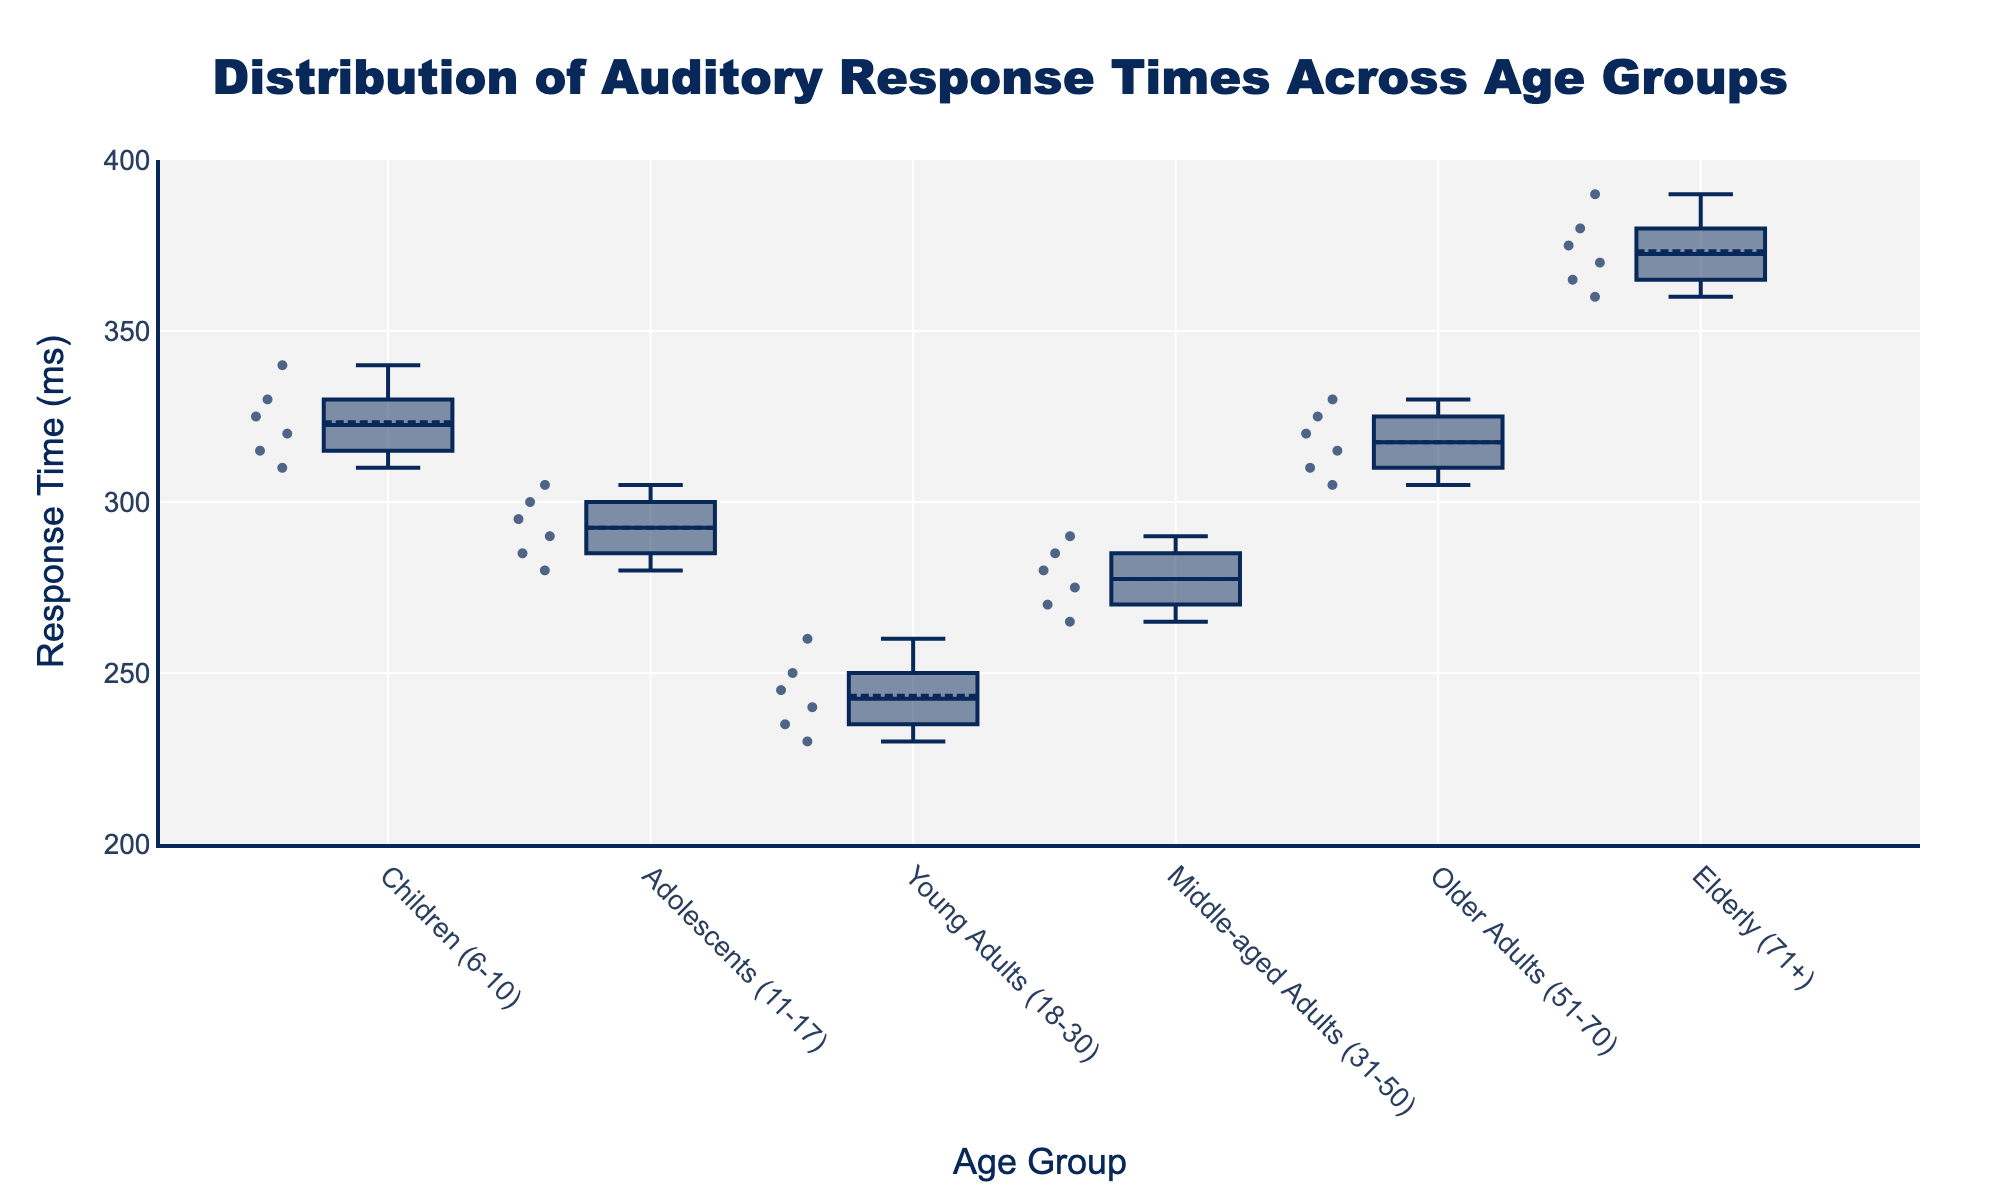What is the title of the figure? The title of the figure is typically found at the top and centers the main concept being visualized. In this case, it is "Distribution of Auditory Response Times Across Age Groups" as mentioned in the code provided.
Answer: Distribution of Auditory Response Times Across Age Groups Which age group has the highest median response time? To find the age group with the highest median, locate the median line inside the boxes of each age group. The highest median line is found in the "Elderly (71+)" group.
Answer: Elderly (71+) What's the range of response times for "Young Adults (18-30)"? The range of a box plot is determined by the whiskers (minimum and maximum values). For "Young Adults (18-30)", the minimum is 230 ms and the maximum is 260 ms, so the range is 260 - 230 = 30 ms.
Answer: 30 ms How many age groups are represented in the plot? The number of age groups can be observed on the x-axis where each group's name appears. There are six age groups listed. Count them to verify: Children (6-10), Adolescents (11-17), Young Adults (18-30), Middle-aged Adults (31-50), Older Adults (51-70), Elderly (71+).
Answer: 6 Which age group has the smallest interquartile range (IQR)? IQR in a box plot is the length of the box, representing the range between the 1st quartile (Q1) and the 3rd quartile (Q3). Visually, the "Young Adults (18-30)" group has the smallest box, indicating the smallest IQR.
Answer: Young Adults (18-30) What is the median response time for "Middle-aged Adults (31-50)"? The median of "Middle-aged Adults (31-50)" is at the line within the box for this group. Visually identify this median line value in the box plot which aligns around 277.5 ms.
Answer: 277.5 ms Compare the response times of "Children (6-10)" and "Older Adults (51-70)". Which group has more variability? To determine variability, compare the total spread (range) and the IQR (box length). "Children (6-10)" shows a larger range and box length than "Older Adults (51-70)", indicating greater variability.
Answer: Children (6-10) What is the maximum response time recorded for "Elderly (71+)"? The maximum response time is represented by the upper whisker end. For "Elderly (71+)", this value is at 390 ms.
Answer: 390 ms Is the median response time of "Adolescents (11-17)" greater than that of "Young Adults (18-30)"? Locate the median mark within the boxes of both groups. The median for "Adolescents (11-17)" is higher than "Young Adults (18-30)".
Answer: Yes 